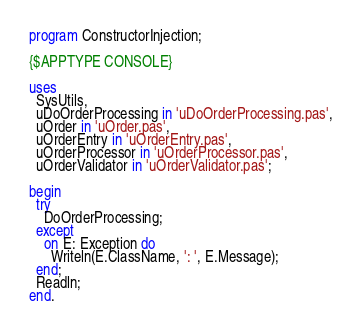<code> <loc_0><loc_0><loc_500><loc_500><_Pascal_>program ConstructorInjection;

{$APPTYPE CONSOLE}

uses
  SysUtils,
  uDoOrderProcessing in 'uDoOrderProcessing.pas',
  uOrder in 'uOrder.pas',
  uOrderEntry in 'uOrderEntry.pas',
  uOrderProcessor in 'uOrderProcessor.pas',
  uOrderValidator in 'uOrderValidator.pas';

begin
  try
    DoOrderProcessing;
  except
    on E: Exception do
      Writeln(E.ClassName, ': ', E.Message);
  end;
  Readln;
end.
</code> 